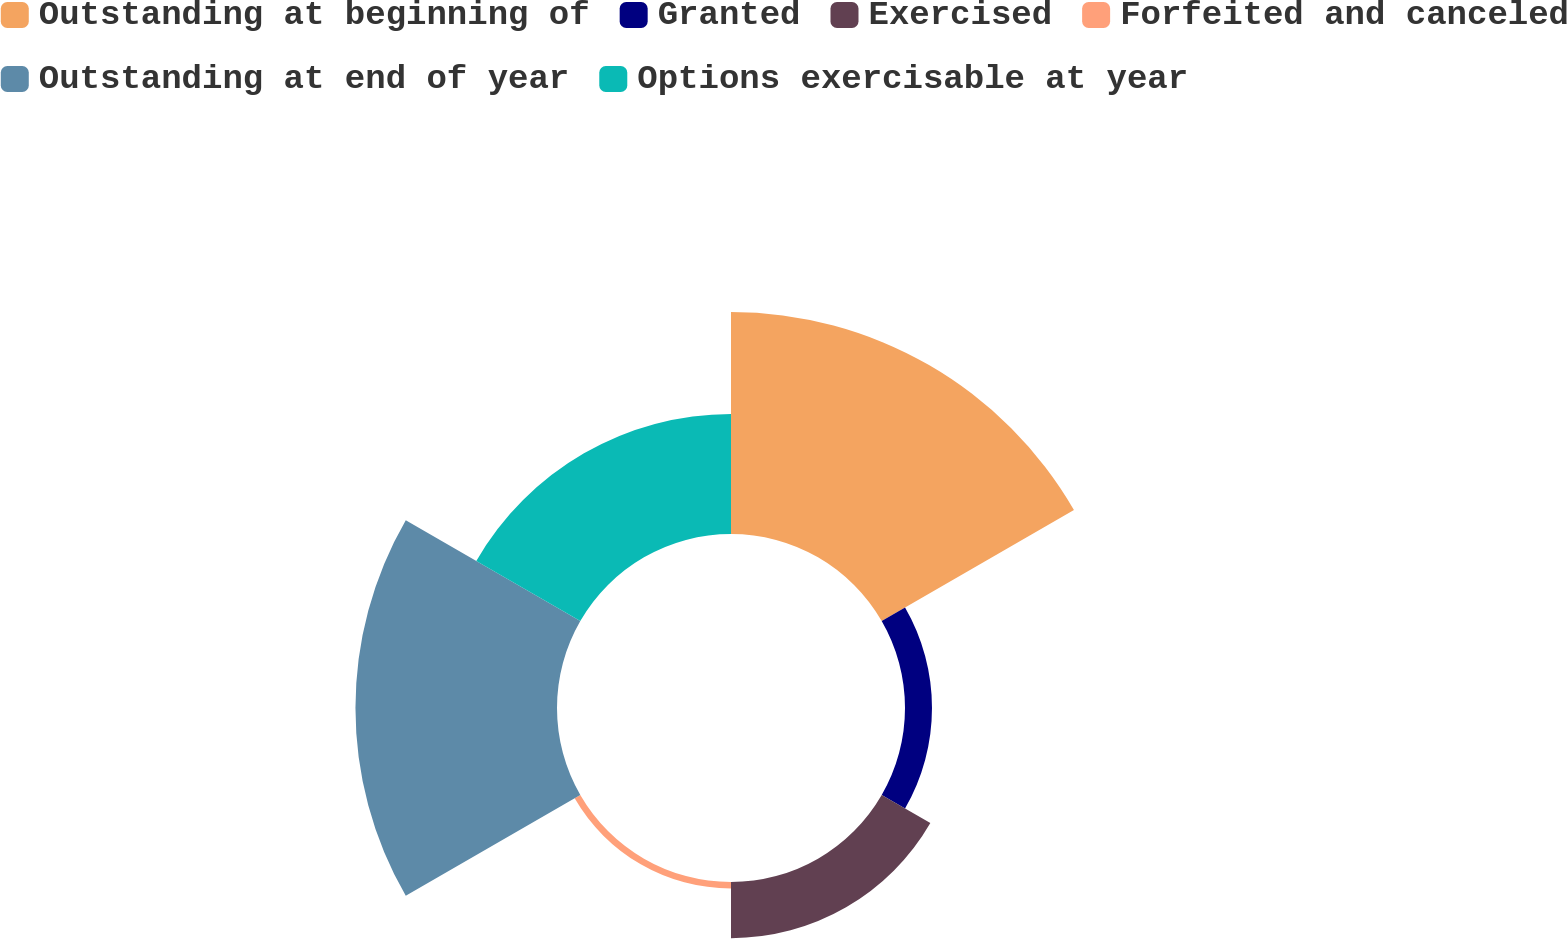Convert chart. <chart><loc_0><loc_0><loc_500><loc_500><pie_chart><fcel>Outstanding at beginning of<fcel>Granted<fcel>Exercised<fcel>Forfeited and canceled<fcel>Outstanding at end of year<fcel>Options exercisable at year<nl><fcel>35.05%<fcel>4.26%<fcel>8.87%<fcel>1.03%<fcel>31.82%<fcel>18.96%<nl></chart> 